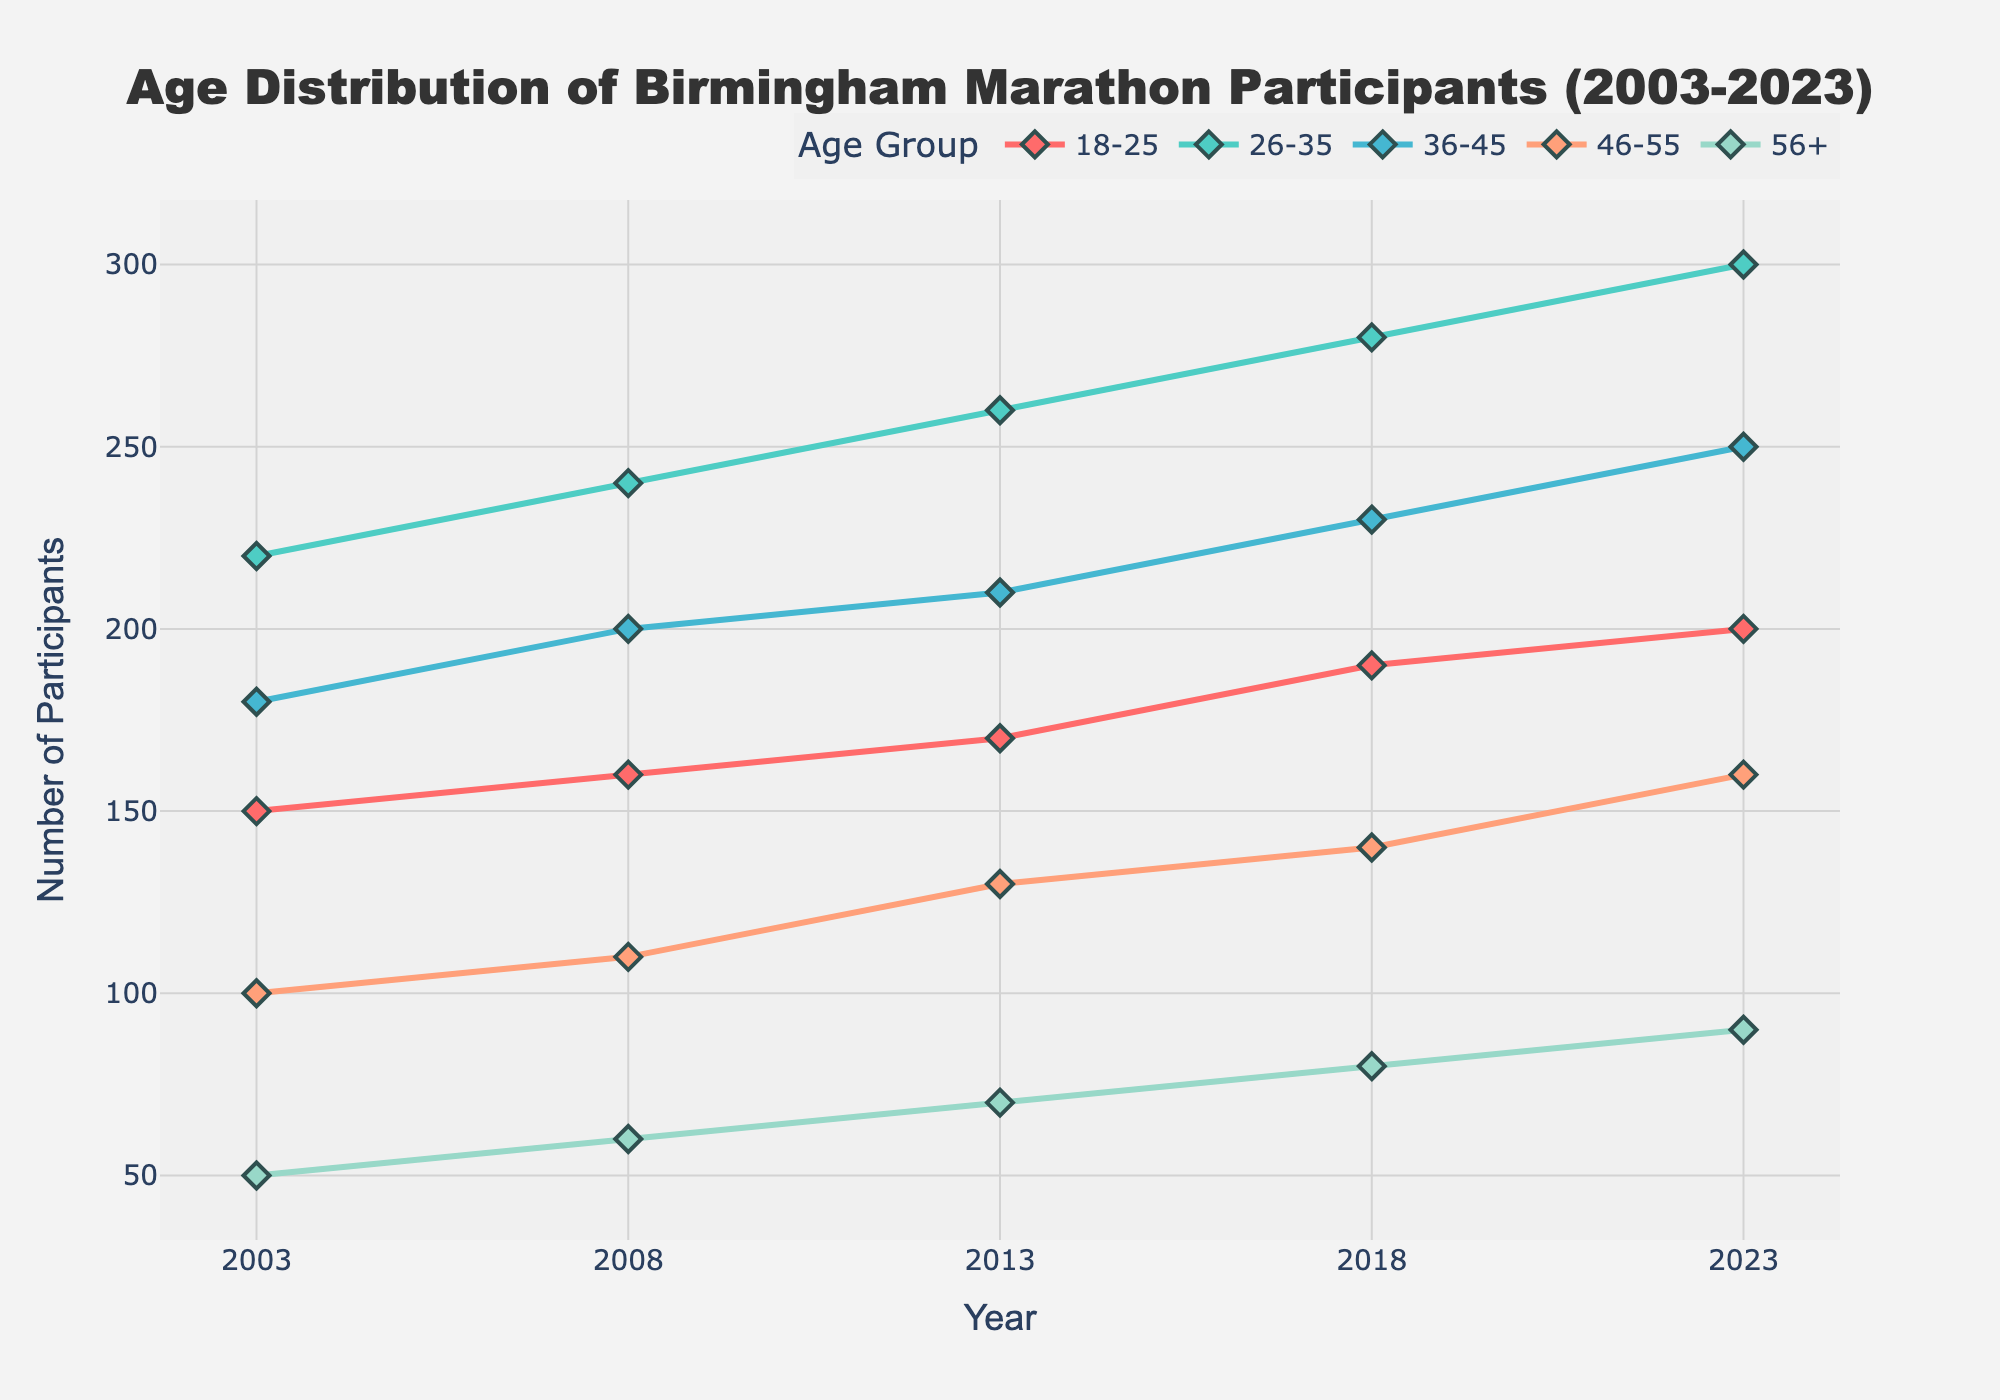What is the title of the plot? The title of the plot is located at the top of the figure.
Answer: Age Distribution of Birmingham Marathon Participants (2003-2023) What is the trend in the number of participants aged 26-35 from 2003 to 2023? Look at the 26-35 age group line in the plot and observe the change in the number of participants every year. It shows an increasing trend across the years.
Answer: Increasing Which age group had the highest number of participants in 2018? Identify the year 2018 on the x-axis, then look for the highest data point value among all age groups' lines. The 26-35 age group has the highest number of participants.
Answer: 26-35 What is the difference in the number of participants aged 36-45 between 2013 and 2023? Find the number of participants for the 36-45 age group in both 2013 and 2023, then subtract the 2013 value from the 2023 value. It's (250 - 210).
Answer: 40 Which age group experienced an increase in participants every year? Observe each age group's line and look for the ones that consistently increase each year (the line is always upward from left to right) over the provided periods.
Answer: 26-35 How did the number of participants aged 56+ change from 2003 to 2023? Compare the number of participants in the 56+ group from 2003 and 2023 directly. The numbers increased from 50 in 2003 to 90 in 2023.
Answer: Increased Which two age groups had the closest number of participants in 2008? Look at the data points for each age group in 2008 and find the two that have the smallest difference in their values. The 46-55 age group had 110 and the 56+ age group had 60.
Answer: 46-55 and 56+ What is the average number of participants aged 18-25 over the years displayed? Add the number of participants for the 18-25 age group from all years and divide by the number of years: (150 + 160 + 170 + 190 + 200) / 5 = 174.
Answer: 174 Which year had the largest overall number of participants for all age groups combined? Sum the participants from all age groups for each year and compare. The sums are: 2003: 700, 2008: 770, 2013: 840, 2018: 920, 2023: 1000. The year 2023 has the largest number.
Answer: 2023 Which age group showed the most significant increase in participants between 2003 and 2023? Calculate the difference for each age group between 2003 and 2023, and identify the maximum increase. The increases are: 18-25: 50, 26-35: 80, 36-45: 70, 46-55: 60, 56+: 40. The 26-35 age group showed the most significant increase.
Answer: 26-35 